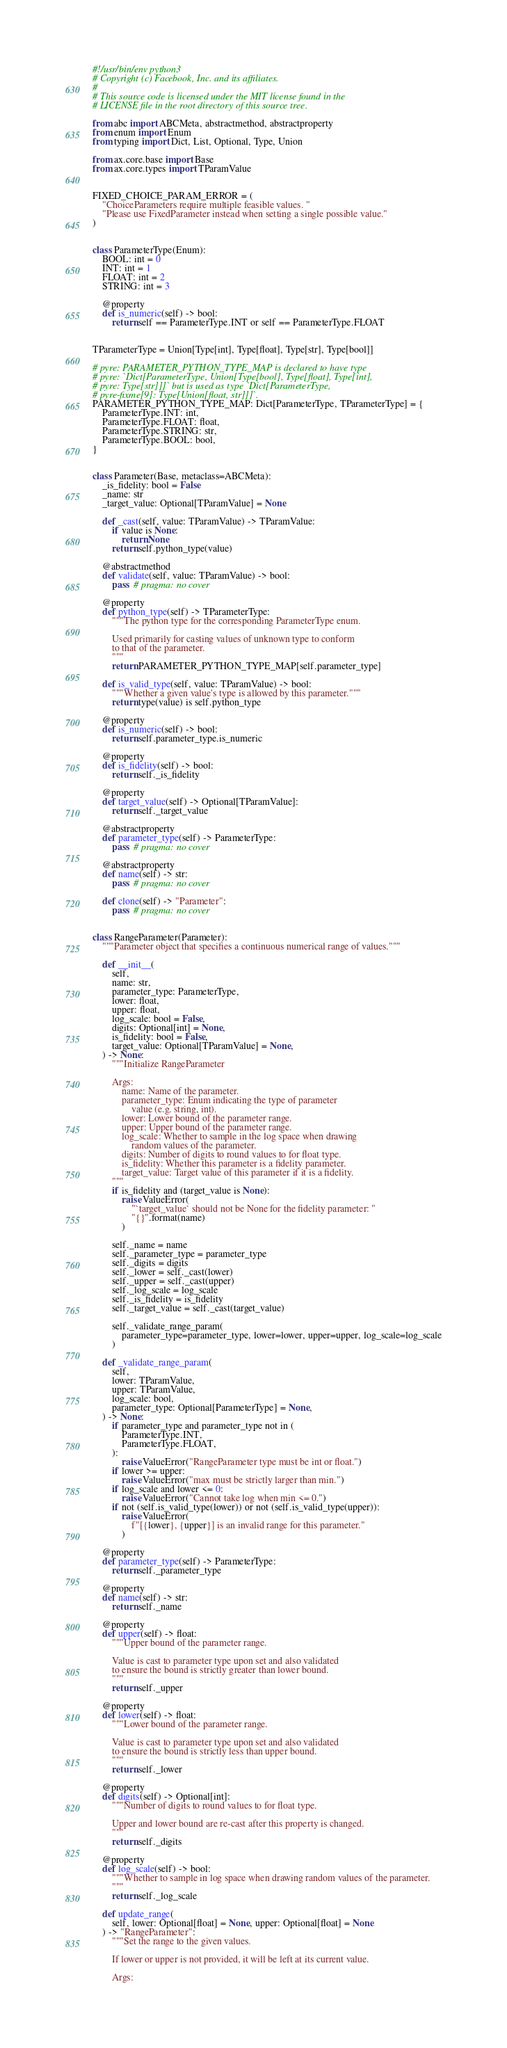<code> <loc_0><loc_0><loc_500><loc_500><_Python_>#!/usr/bin/env python3
# Copyright (c) Facebook, Inc. and its affiliates.
#
# This source code is licensed under the MIT license found in the
# LICENSE file in the root directory of this source tree.

from abc import ABCMeta, abstractmethod, abstractproperty
from enum import Enum
from typing import Dict, List, Optional, Type, Union

from ax.core.base import Base
from ax.core.types import TParamValue


FIXED_CHOICE_PARAM_ERROR = (
    "ChoiceParameters require multiple feasible values. "
    "Please use FixedParameter instead when setting a single possible value."
)


class ParameterType(Enum):
    BOOL: int = 0
    INT: int = 1
    FLOAT: int = 2
    STRING: int = 3

    @property
    def is_numeric(self) -> bool:
        return self == ParameterType.INT or self == ParameterType.FLOAT


TParameterType = Union[Type[int], Type[float], Type[str], Type[bool]]

# pyre: PARAMETER_PYTHON_TYPE_MAP is declared to have type
# pyre: `Dict[ParameterType, Union[Type[bool], Type[float], Type[int],
# pyre: Type[str]]]` but is used as type `Dict[ParameterType,
# pyre-fixme[9]: Type[Union[float, str]]]`.
PARAMETER_PYTHON_TYPE_MAP: Dict[ParameterType, TParameterType] = {
    ParameterType.INT: int,
    ParameterType.FLOAT: float,
    ParameterType.STRING: str,
    ParameterType.BOOL: bool,
}


class Parameter(Base, metaclass=ABCMeta):
    _is_fidelity: bool = False
    _name: str
    _target_value: Optional[TParamValue] = None

    def _cast(self, value: TParamValue) -> TParamValue:
        if value is None:
            return None
        return self.python_type(value)

    @abstractmethod
    def validate(self, value: TParamValue) -> bool:
        pass  # pragma: no cover

    @property
    def python_type(self) -> TParameterType:
        """The python type for the corresponding ParameterType enum.

        Used primarily for casting values of unknown type to conform
        to that of the parameter.
        """
        return PARAMETER_PYTHON_TYPE_MAP[self.parameter_type]

    def is_valid_type(self, value: TParamValue) -> bool:
        """Whether a given value's type is allowed by this parameter."""
        return type(value) is self.python_type

    @property
    def is_numeric(self) -> bool:
        return self.parameter_type.is_numeric

    @property
    def is_fidelity(self) -> bool:
        return self._is_fidelity

    @property
    def target_value(self) -> Optional[TParamValue]:
        return self._target_value

    @abstractproperty
    def parameter_type(self) -> ParameterType:
        pass  # pragma: no cover

    @abstractproperty
    def name(self) -> str:
        pass  # pragma: no cover

    def clone(self) -> "Parameter":
        pass  # pragma: no cover


class RangeParameter(Parameter):
    """Parameter object that specifies a continuous numerical range of values."""

    def __init__(
        self,
        name: str,
        parameter_type: ParameterType,
        lower: float,
        upper: float,
        log_scale: bool = False,
        digits: Optional[int] = None,
        is_fidelity: bool = False,
        target_value: Optional[TParamValue] = None,
    ) -> None:
        """Initialize RangeParameter

        Args:
            name: Name of the parameter.
            parameter_type: Enum indicating the type of parameter
                value (e.g. string, int).
            lower: Lower bound of the parameter range.
            upper: Upper bound of the parameter range.
            log_scale: Whether to sample in the log space when drawing
                random values of the parameter.
            digits: Number of digits to round values to for float type.
            is_fidelity: Whether this parameter is a fidelity parameter.
            target_value: Target value of this parameter if it is a fidelity.
        """
        if is_fidelity and (target_value is None):
            raise ValueError(
                "`target_value` should not be None for the fidelity parameter: "
                "{}".format(name)
            )

        self._name = name
        self._parameter_type = parameter_type
        self._digits = digits
        self._lower = self._cast(lower)
        self._upper = self._cast(upper)
        self._log_scale = log_scale
        self._is_fidelity = is_fidelity
        self._target_value = self._cast(target_value)

        self._validate_range_param(
            parameter_type=parameter_type, lower=lower, upper=upper, log_scale=log_scale
        )

    def _validate_range_param(
        self,
        lower: TParamValue,
        upper: TParamValue,
        log_scale: bool,
        parameter_type: Optional[ParameterType] = None,
    ) -> None:
        if parameter_type and parameter_type not in (
            ParameterType.INT,
            ParameterType.FLOAT,
        ):
            raise ValueError("RangeParameter type must be int or float.")
        if lower >= upper:
            raise ValueError("max must be strictly larger than min.")
        if log_scale and lower <= 0:
            raise ValueError("Cannot take log when min <= 0.")
        if not (self.is_valid_type(lower)) or not (self.is_valid_type(upper)):
            raise ValueError(
                f"[{lower}, {upper}] is an invalid range for this parameter."
            )

    @property
    def parameter_type(self) -> ParameterType:
        return self._parameter_type

    @property
    def name(self) -> str:
        return self._name

    @property
    def upper(self) -> float:
        """Upper bound of the parameter range.

        Value is cast to parameter type upon set and also validated
        to ensure the bound is strictly greater than lower bound.
        """
        return self._upper

    @property
    def lower(self) -> float:
        """Lower bound of the parameter range.

        Value is cast to parameter type upon set and also validated
        to ensure the bound is strictly less than upper bound.
        """
        return self._lower

    @property
    def digits(self) -> Optional[int]:
        """Number of digits to round values to for float type.

        Upper and lower bound are re-cast after this property is changed.
        """
        return self._digits

    @property
    def log_scale(self) -> bool:
        """Whether to sample in log space when drawing random values of the parameter.
        """
        return self._log_scale

    def update_range(
        self, lower: Optional[float] = None, upper: Optional[float] = None
    ) -> "RangeParameter":
        """Set the range to the given values.

        If lower or upper is not provided, it will be left at its current value.

        Args:</code> 